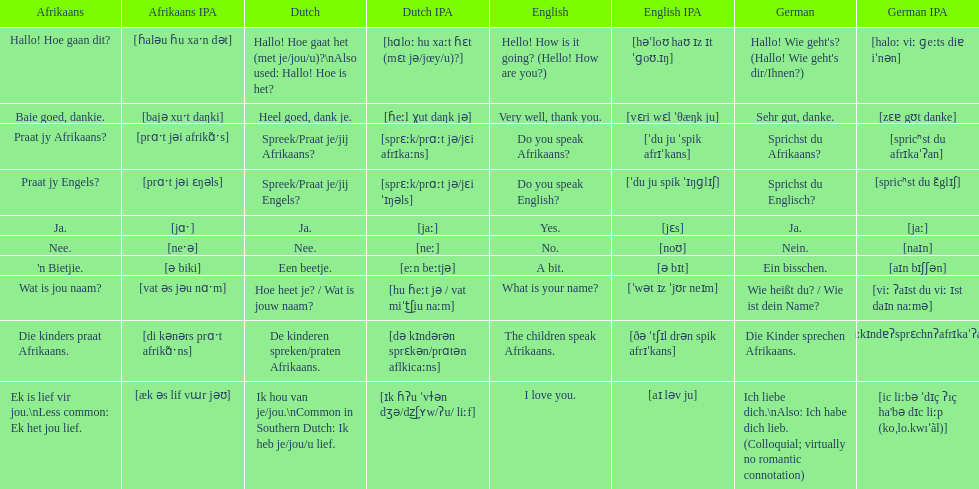How do you say 'yes' in afrikaans? Ja. 